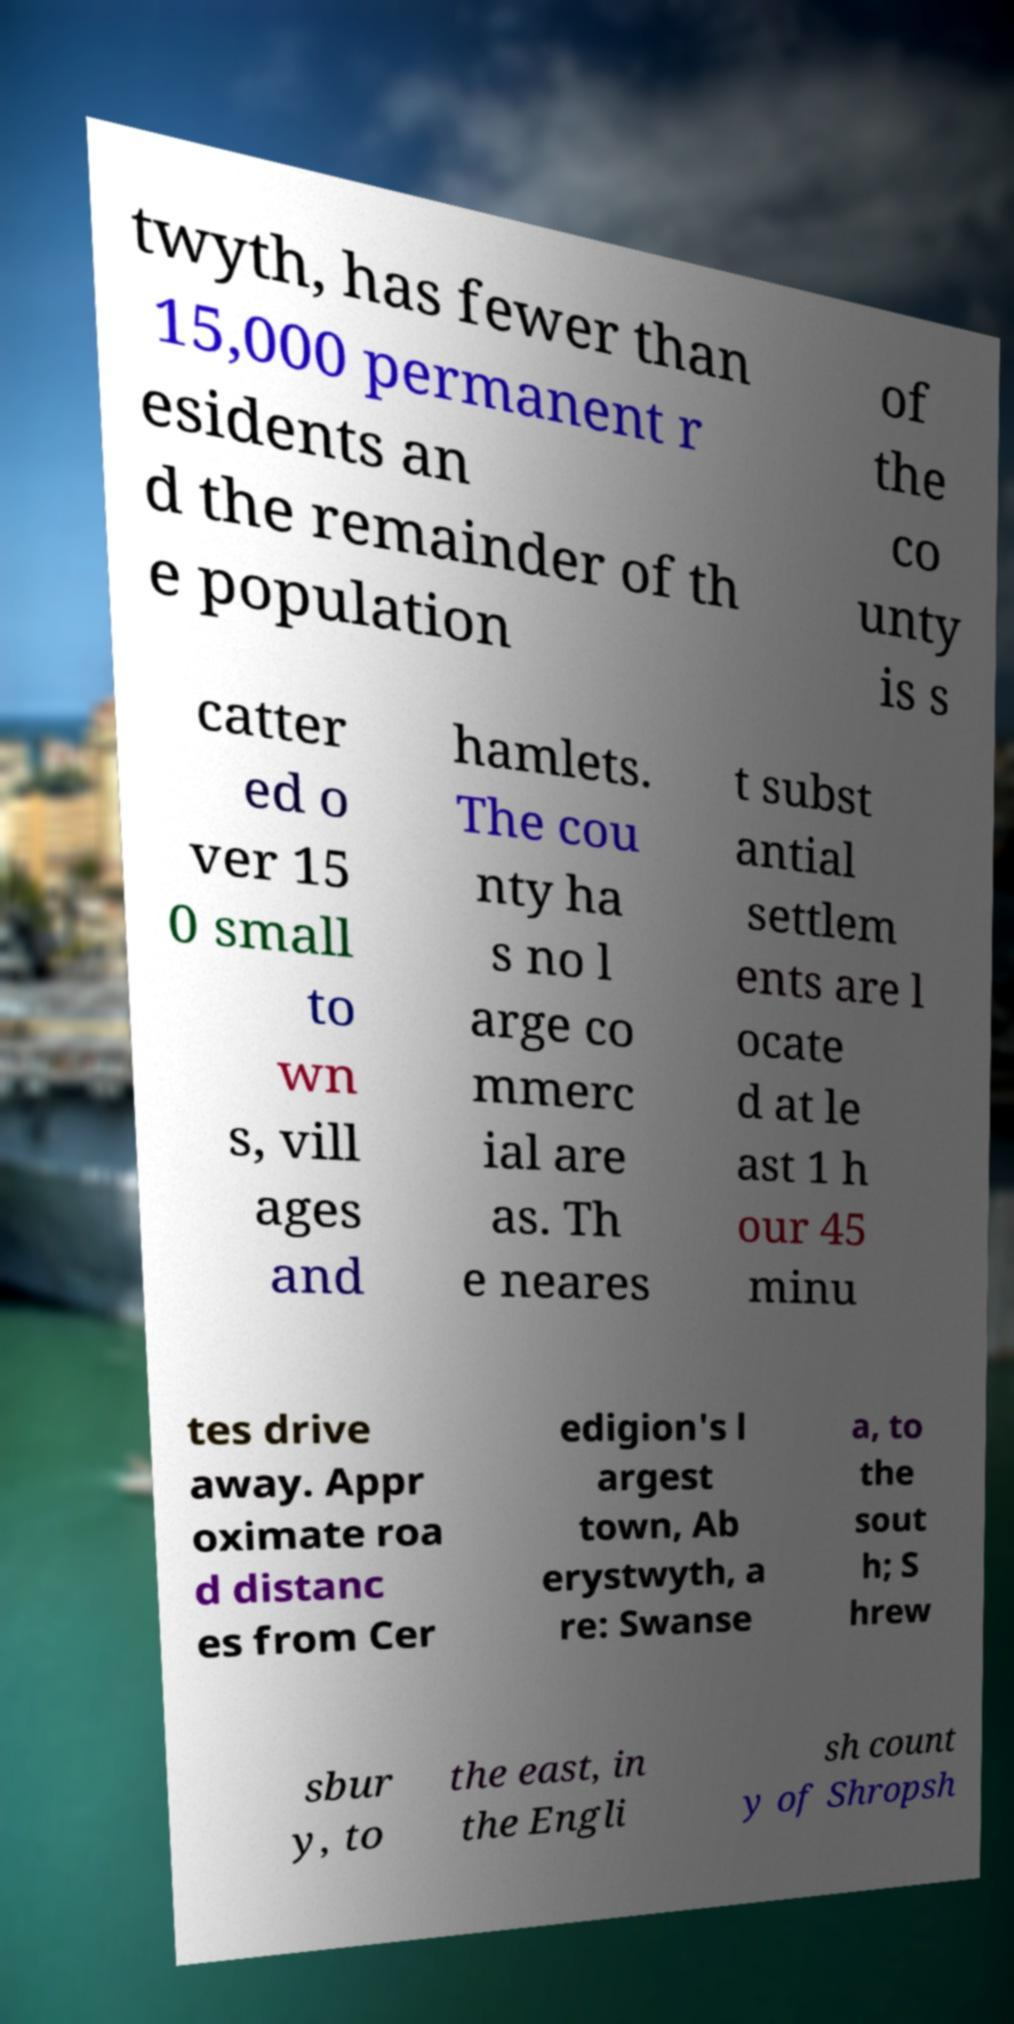I need the written content from this picture converted into text. Can you do that? twyth, has fewer than 15,000 permanent r esidents an d the remainder of th e population of the co unty is s catter ed o ver 15 0 small to wn s, vill ages and hamlets. The cou nty ha s no l arge co mmerc ial are as. Th e neares t subst antial settlem ents are l ocate d at le ast 1 h our 45 minu tes drive away. Appr oximate roa d distanc es from Cer edigion's l argest town, Ab erystwyth, a re: Swanse a, to the sout h; S hrew sbur y, to the east, in the Engli sh count y of Shropsh 